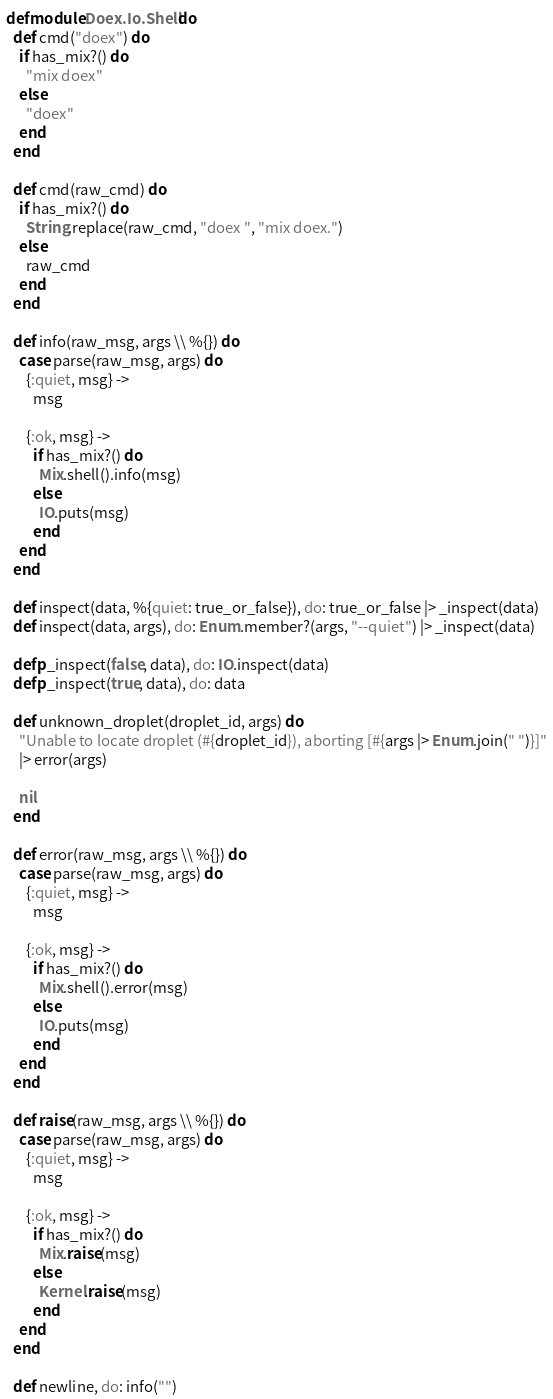<code> <loc_0><loc_0><loc_500><loc_500><_Elixir_>defmodule Doex.Io.Shell do
  def cmd("doex") do
    if has_mix?() do
      "mix doex"
    else
      "doex"
    end
  end

  def cmd(raw_cmd) do
    if has_mix?() do
      String.replace(raw_cmd, "doex ", "mix doex.")
    else
      raw_cmd
    end
  end

  def info(raw_msg, args \\ %{}) do
    case parse(raw_msg, args) do
      {:quiet, msg} ->
        msg

      {:ok, msg} ->
        if has_mix?() do
          Mix.shell().info(msg)
        else
          IO.puts(msg)
        end
    end
  end

  def inspect(data, %{quiet: true_or_false}), do: true_or_false |> _inspect(data)
  def inspect(data, args), do: Enum.member?(args, "--quiet") |> _inspect(data)

  defp _inspect(false, data), do: IO.inspect(data)
  defp _inspect(true, data), do: data

  def unknown_droplet(droplet_id, args) do
    "Unable to locate droplet (#{droplet_id}), aborting [#{args |> Enum.join(" ")}]"
    |> error(args)

    nil
  end

  def error(raw_msg, args \\ %{}) do
    case parse(raw_msg, args) do
      {:quiet, msg} ->
        msg

      {:ok, msg} ->
        if has_mix?() do
          Mix.shell().error(msg)
        else
          IO.puts(msg)
        end
    end
  end

  def raise(raw_msg, args \\ %{}) do
    case parse(raw_msg, args) do
      {:quiet, msg} ->
        msg

      {:ok, msg} ->
        if has_mix?() do
          Mix.raise(msg)
        else
          Kernel.raise(msg)
        end
    end
  end

  def newline, do: info("")
</code> 